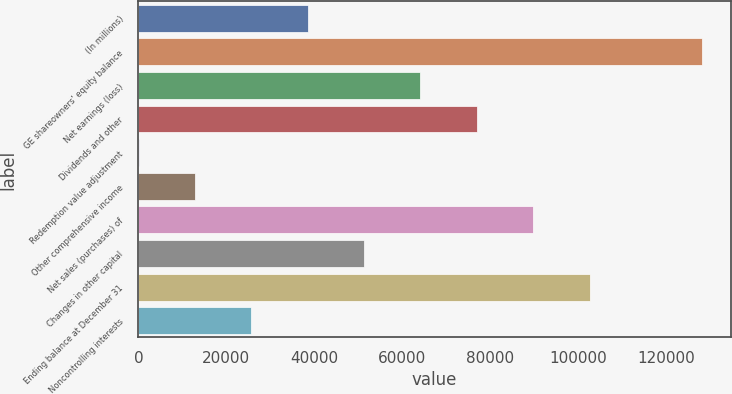Convert chart to OTSL. <chart><loc_0><loc_0><loc_500><loc_500><bar_chart><fcel>(In millions)<fcel>GE shareowners' equity balance<fcel>Net earnings (loss)<fcel>Dividends and other<fcel>Redemption value adjustment<fcel>Other comprehensive income<fcel>Net sales (purchases) of<fcel>Changes in other capital<fcel>Ending balance at December 31<fcel>Noncontrolling interests<nl><fcel>38465.2<fcel>128159<fcel>64092<fcel>76905.4<fcel>25<fcel>12838.4<fcel>89718.8<fcel>51278.6<fcel>102532<fcel>25651.8<nl></chart> 